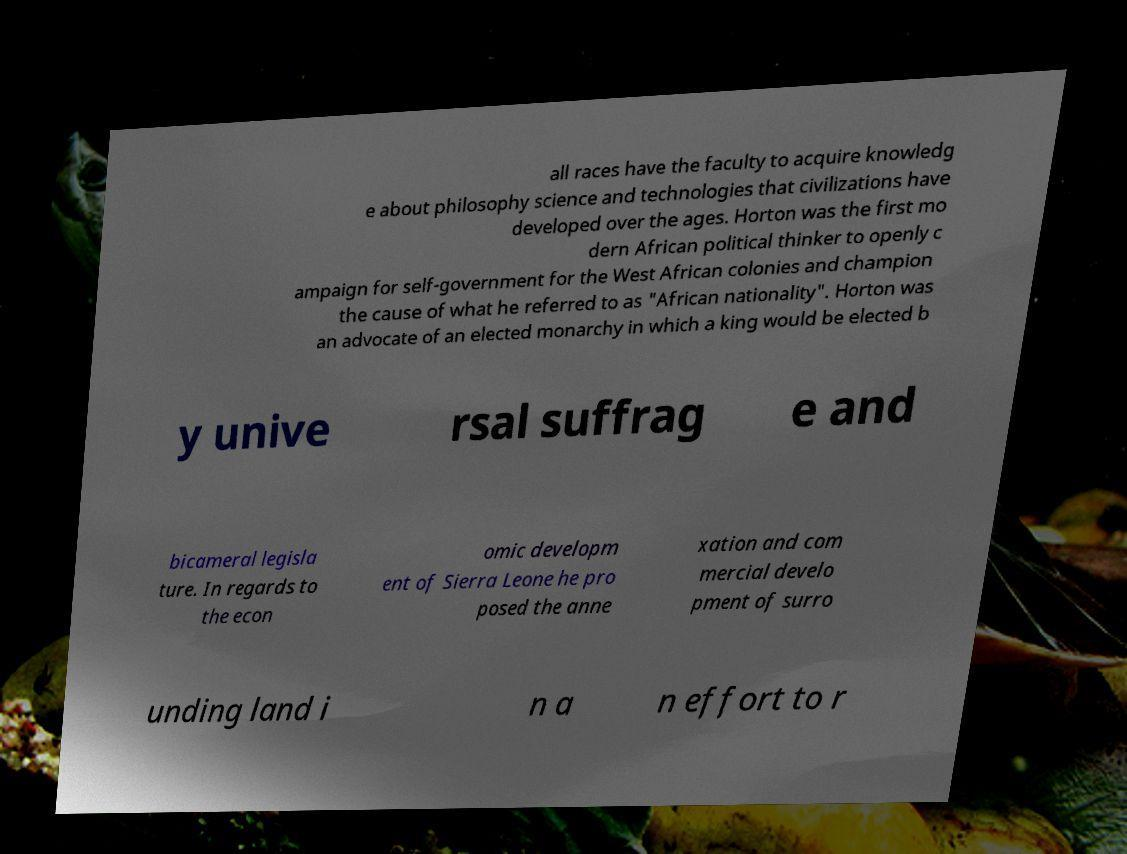What messages or text are displayed in this image? I need them in a readable, typed format. all races have the faculty to acquire knowledg e about philosophy science and technologies that civilizations have developed over the ages. Horton was the first mo dern African political thinker to openly c ampaign for self-government for the West African colonies and champion the cause of what he referred to as "African nationality". Horton was an advocate of an elected monarchy in which a king would be elected b y unive rsal suffrag e and bicameral legisla ture. In regards to the econ omic developm ent of Sierra Leone he pro posed the anne xation and com mercial develo pment of surro unding land i n a n effort to r 